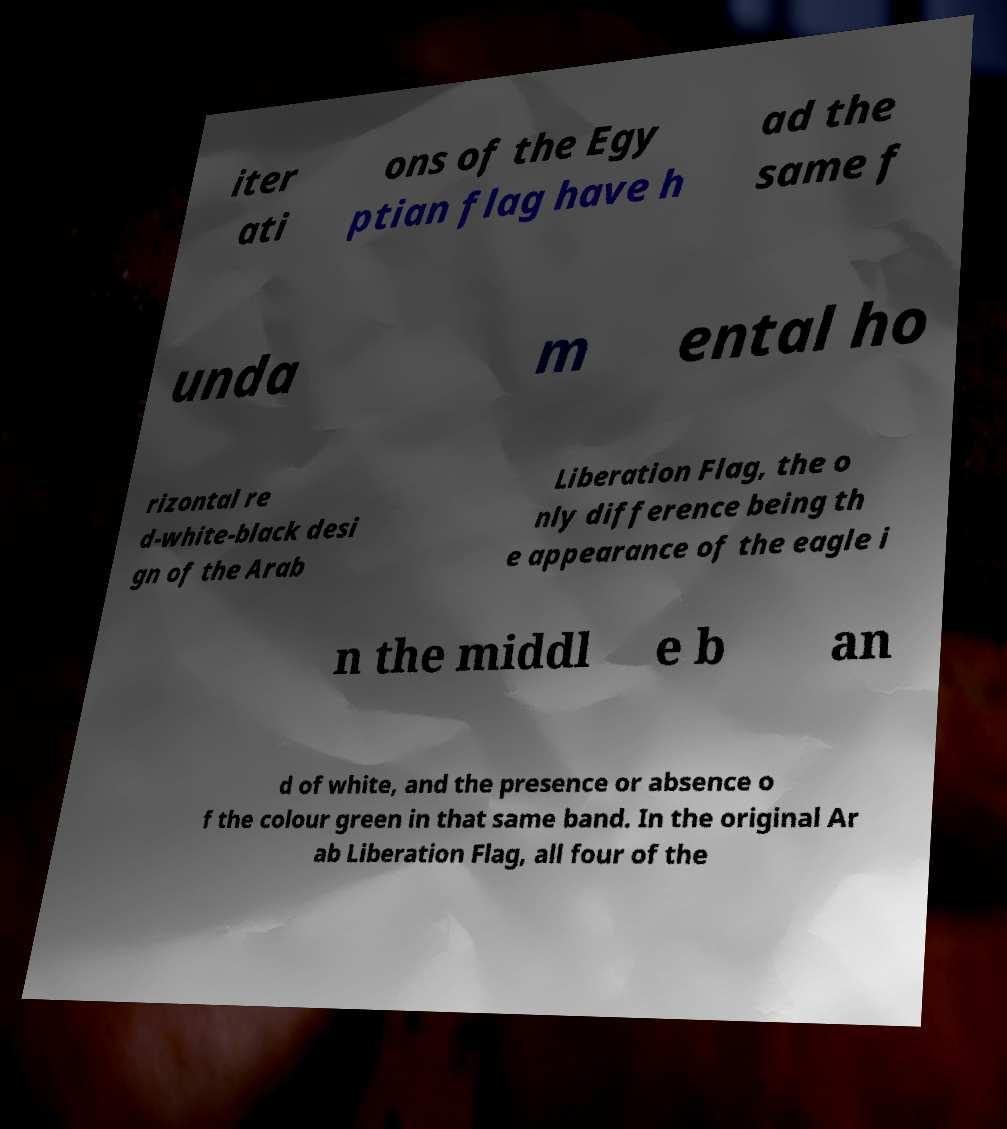Could you extract and type out the text from this image? iter ati ons of the Egy ptian flag have h ad the same f unda m ental ho rizontal re d-white-black desi gn of the Arab Liberation Flag, the o nly difference being th e appearance of the eagle i n the middl e b an d of white, and the presence or absence o f the colour green in that same band. In the original Ar ab Liberation Flag, all four of the 